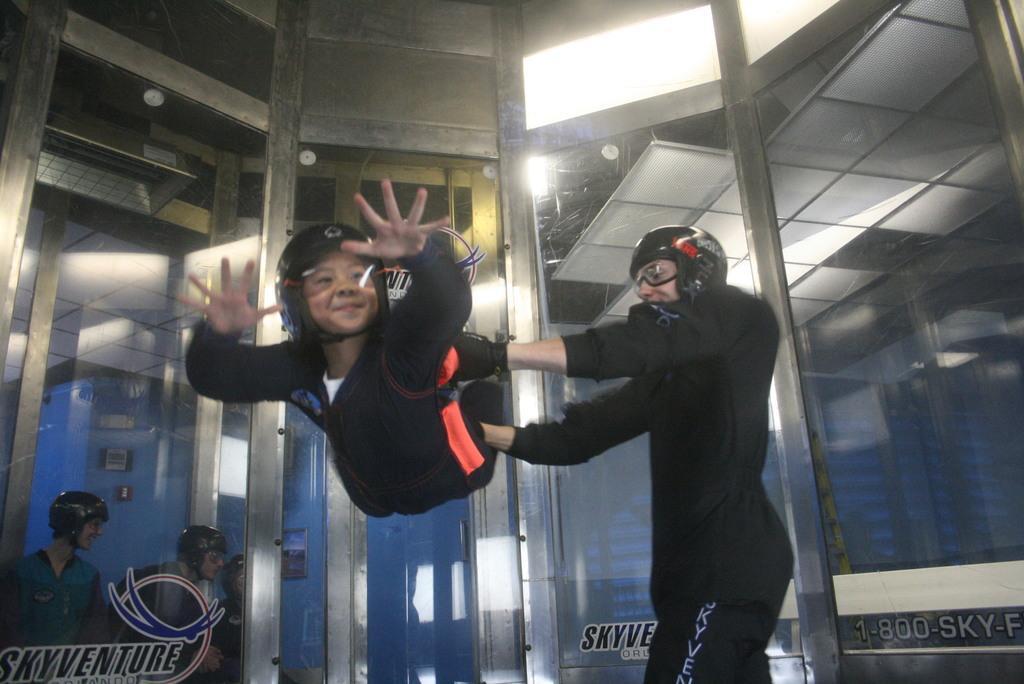In one or two sentences, can you explain what this image depicts? In this image there is one person standing on the right side of this image is wearing black color dress and there is one kid is in the air as we can see in the middle of this image. There are some glass doors in the background. there are some other persons in the bottom left corner of this image. 